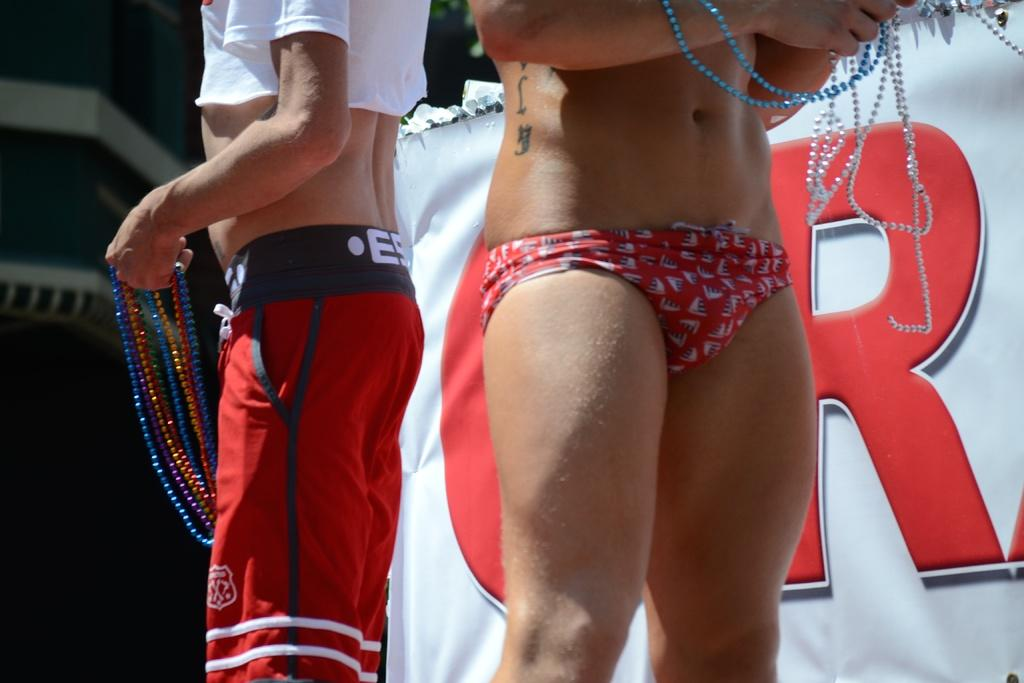<image>
Describe the image concisely. Spring break party with two people standing in front of a sign with the letter R on it. 